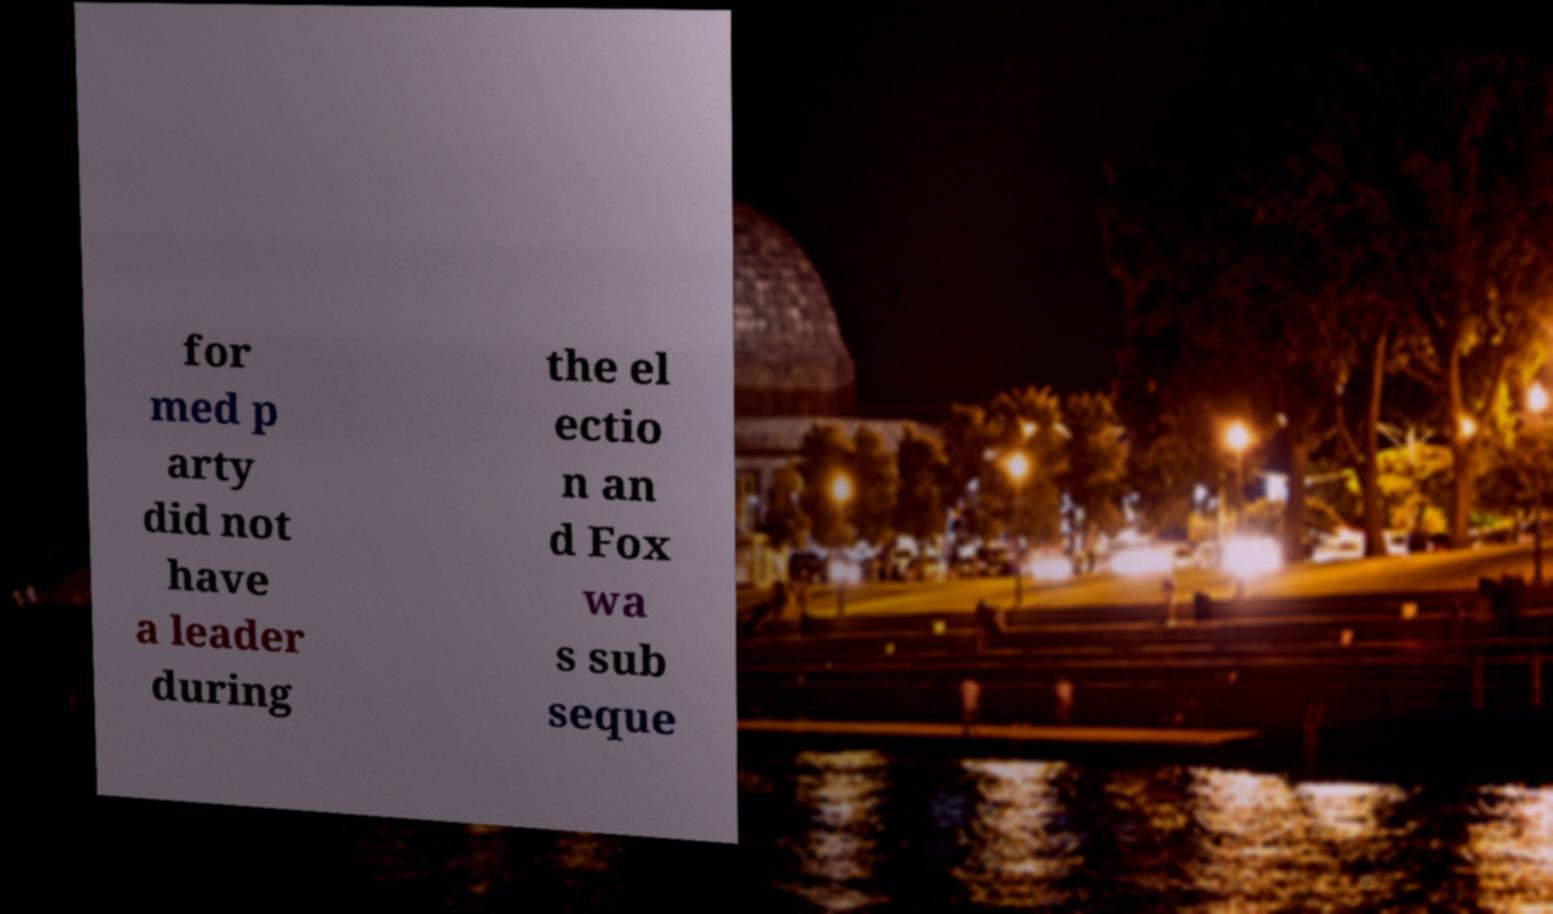Can you read and provide the text displayed in the image?This photo seems to have some interesting text. Can you extract and type it out for me? for med p arty did not have a leader during the el ectio n an d Fox wa s sub seque 